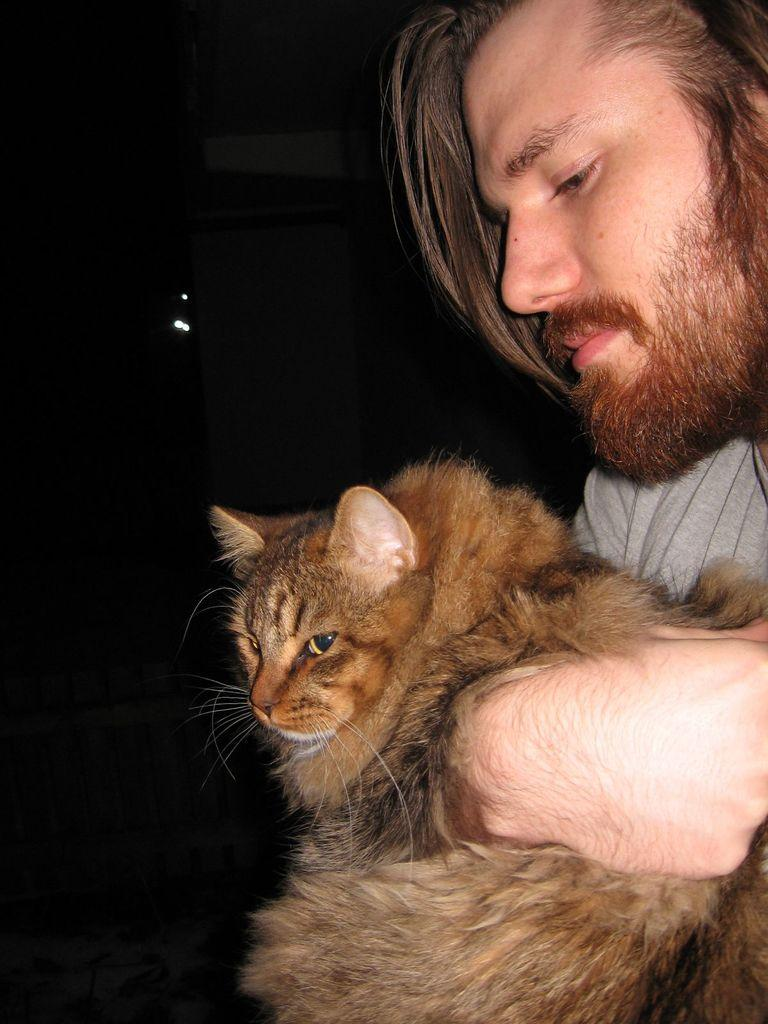What type of animal is in the image? There is a cat in the image. What is the cat doing in the image? A person is holding the cat. Can you describe the person holding the cat? The person has a beard and silky hair. What type of juice is the person drinking in the image? There is no juice present in the image; the person is holding a cat. 